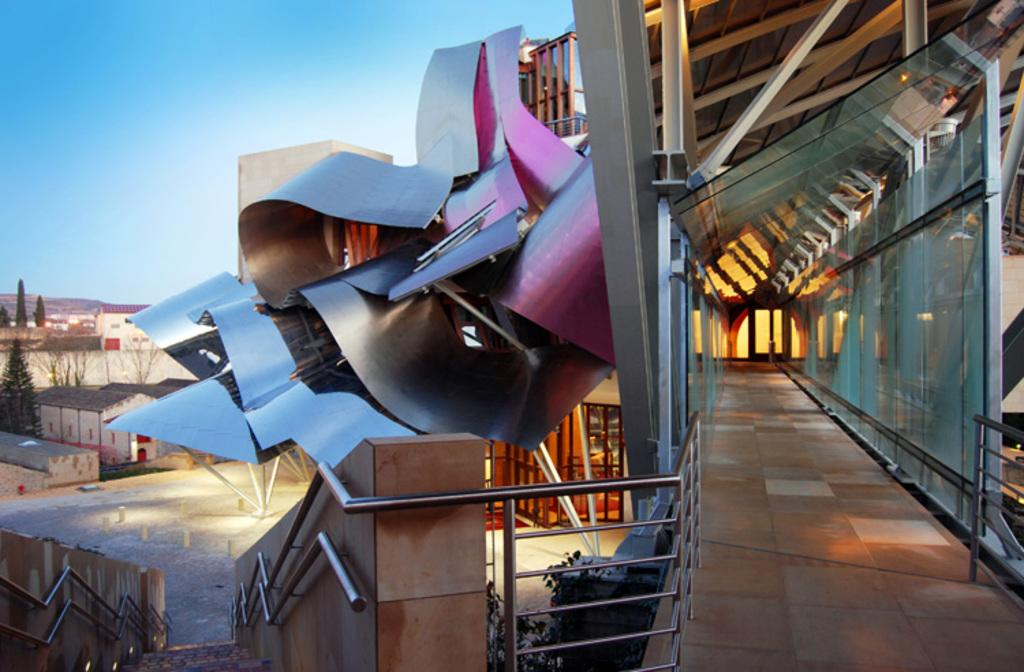What type of carpenter can be seen working in the image? There is no carpenter present in the image. Is there a grandmother in the image? There is no grandmother present in the image. What type of activity is taking place in the image? The image shows buildings, a framed glass wall, stairs, trees, and other objects on the ground, with the sky visible in the background. What type of camp can be seen in the image? There is no camp present in the image. 